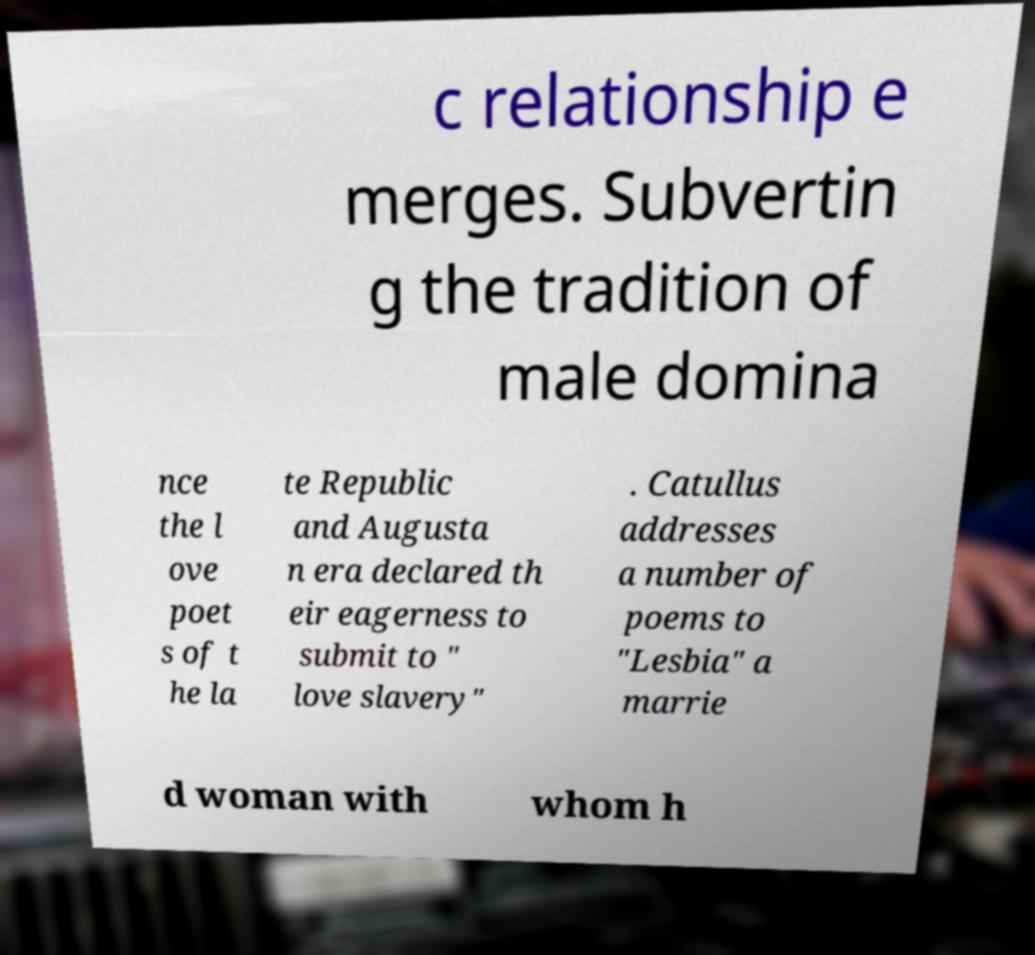Can you read and provide the text displayed in the image?This photo seems to have some interesting text. Can you extract and type it out for me? c relationship e merges. Subvertin g the tradition of male domina nce the l ove poet s of t he la te Republic and Augusta n era declared th eir eagerness to submit to " love slavery" . Catullus addresses a number of poems to "Lesbia" a marrie d woman with whom h 